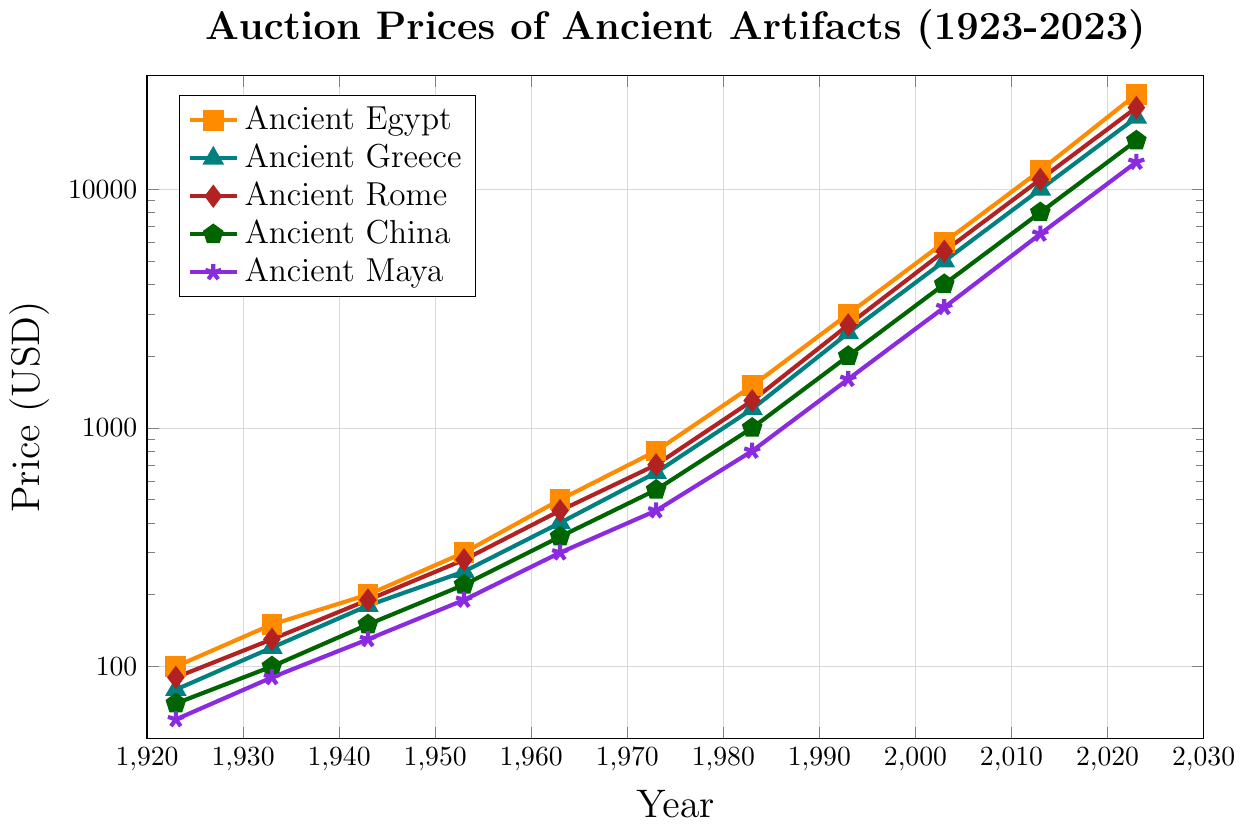What is the price of Ancient Maya artifacts in 1943? Look at the value on the plot for Ancient Maya in the year 1943. The corresponding auction price is displayed next to the point.
Answer: 130 Which civilization showed the highest increase in auction prices between 1923 and 2023? Compare the price values for each civilization from 1923 to 2023. Ancient Egypt's prices increased from 100 to 25000, showing the highest increase.
Answer: Ancient Egypt By how much did the price for Ancient Greek artifacts change from 1963 to 1983? Find the values for Ancient Greece at 1963 (400) and 1983 (1200), then subtract the former from the latter to get the change: 1200 - 400 = 800.
Answer: 800 If you average the prices of Ancient Roman artifacts in 1953 and 2003, what value do you get? To find the average, add the prices for Ancient Rome in 1953 (280) and 2003 (5500), and then divide by 2: (280 + 5500) / 2 = 2890.
Answer: 2890 Which year shows the first-time auction prices for Ancient Chinese artifacts exceeded 5000 USD? Check the values for Ancient China over the years and identify the first year where the value surpasses 5000. In 2023, the price (16000) exceeds 5000 for the first time.
Answer: 2023 Compare the prices of Ancient Egyptian and Ancient Roman artifacts in 1933; which is higher and by how much? Look at the values for 1933: Ancient Egypt (150) and Ancient Rome (130). Subtract the lower value from the higher one to find the difference: 150 - 130 = 20.
Answer: Ancient Egypt, by 20 Which period saw the fastest growth rate in auction prices for Ancient Greek artifacts? Observe the trend line for Ancient Greece and look at the steepness. The period from 1953 to 1983 shows a rapid increase from 250 to 1200 USD.
Answer: 1953-1983 What color represents Ancient Chinese artifacts in the chart? Identify the color assigned to each line in the legend. Ancient China is represented by the green line.
Answer: Green How did the artifact prices of Ancient Maya change from 1993 to 2013? Compare the prices in 1993 (1600) and 2013 (6500). Subtract the earlier price from the later price: 6500 - 1600 = 4900.
Answer: Increase by 4900 